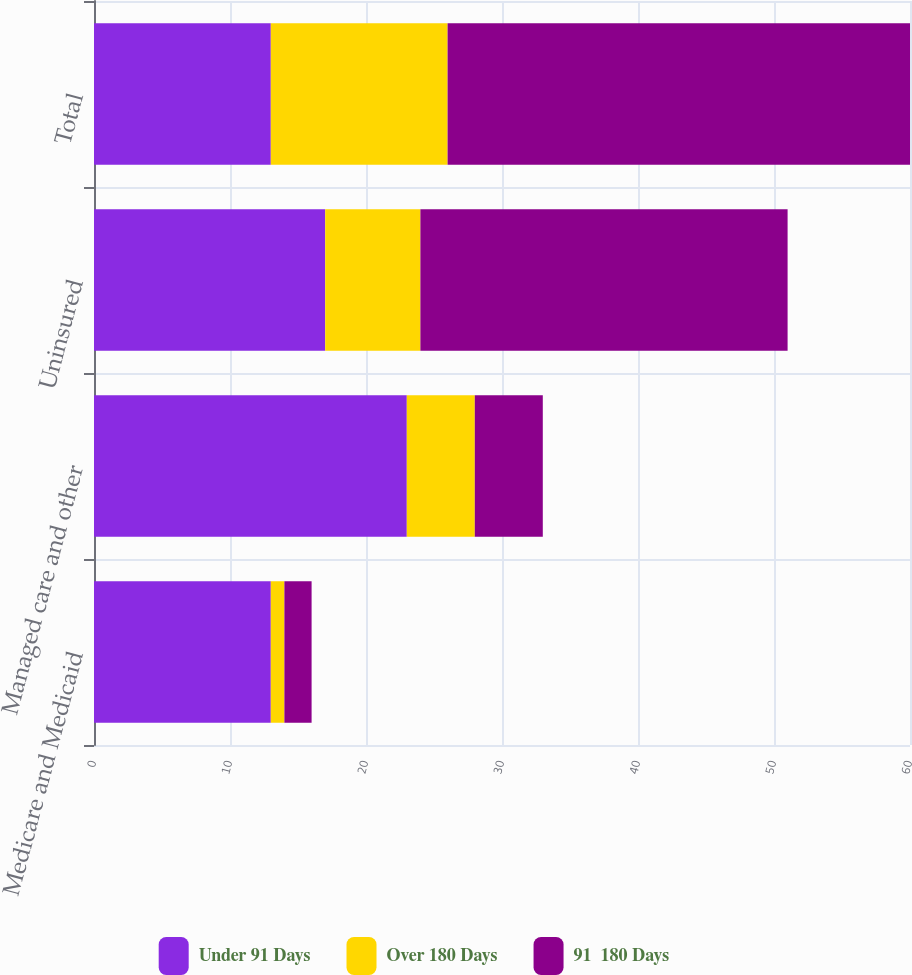Convert chart. <chart><loc_0><loc_0><loc_500><loc_500><stacked_bar_chart><ecel><fcel>Medicare and Medicaid<fcel>Managed care and other<fcel>Uninsured<fcel>Total<nl><fcel>Under 91 Days<fcel>13<fcel>23<fcel>17<fcel>13<nl><fcel>Over 180 Days<fcel>1<fcel>5<fcel>7<fcel>13<nl><fcel>91  180 Days<fcel>2<fcel>5<fcel>27<fcel>34<nl></chart> 